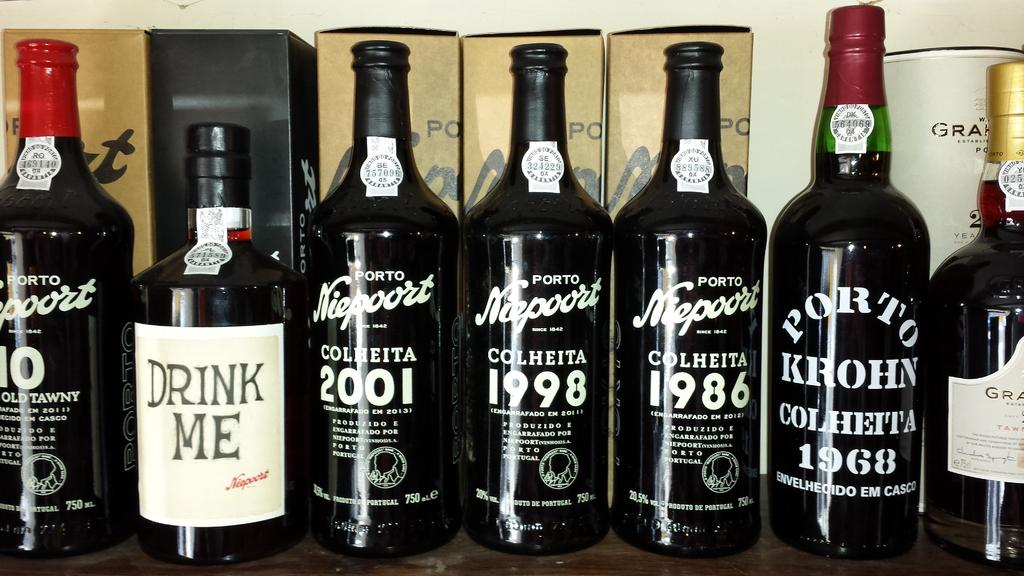What type of objects are present in the image? There is a group of glass bottles in the image. Can you describe the material of the objects? The objects are made of glass. How many bottles are in the group? The number of bottles is not specified in the provided facts, so we cannot determine the exact number. Reasoning: Leting: Let's think step by step in order to produce the conversation. We start by identifying the main subject in the image, which is the group of glass bottles. Then, we describe the material of the objects to provide more detail about the bottles. Finally, we acknowledge that the number of bottles is not specified in the provided facts, so we cannot determine the exact number. Absurd Question/Answer: What type of brass rings can be seen on the slip in the image? There is no mention of brass rings or a slip in the provided facts, so we cannot answer this question. 